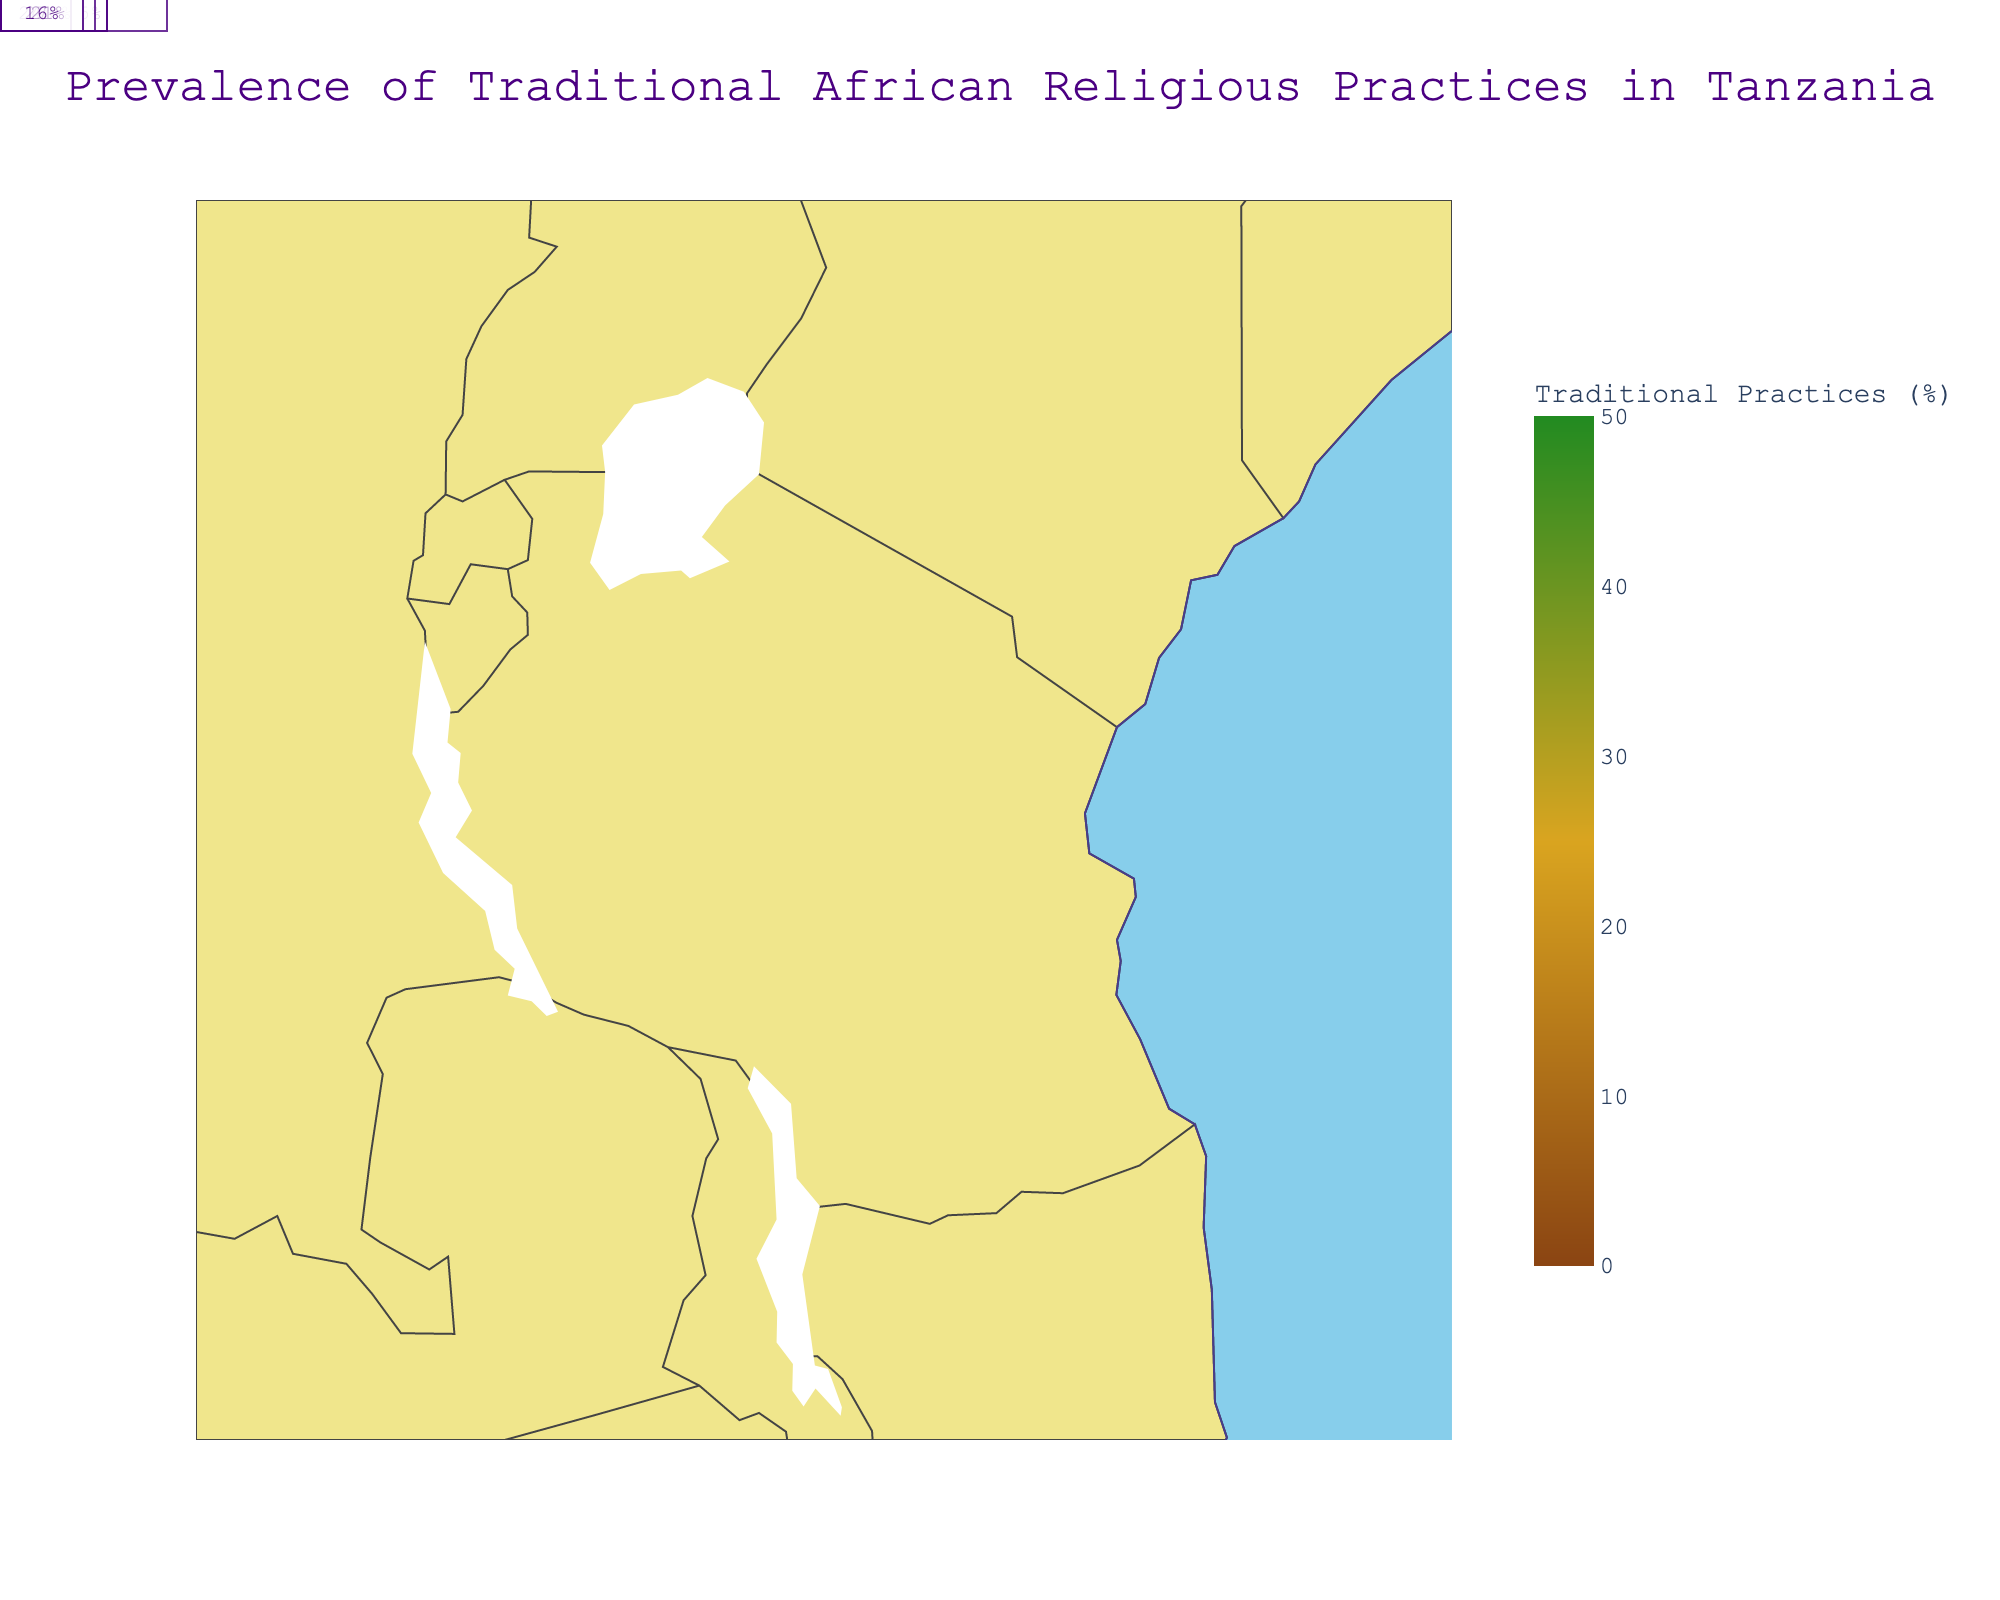What is the title of the figure? The title of the figure is displayed prominently at the top and it describes the subject of the plot. From the information given, the title is stated in the code as "Prevalence of Traditional African Religious Practices in Tanzania".
Answer: Prevalence of Traditional African Religious Practices in Tanzania Which district has the highest prevalence of traditional practices? To determine the district with the highest prevalence, look at the color-coded scale and the corresponding percentages. Zanzibar has the highest percentage at 45%.
Answer: Zanzibar How does the prevalence of traditional practices in Mtwara compare to that in Arusha? First, find Mtwara's prevalence of traditional practices which is 38%. Then, find Arusha's prevalence which is 28%. Comparing the two, Mtwara has a higher prevalence.
Answer: Mtwara has a higher prevalence Which district has the lowest prevalence of traditional practices? Identify the lowest percentage from the color scale and annotations. Mbeya has the lowest prevalence of traditional practices at 12%.
Answer: Mbeya What is the range of traditional practices prevalence across all districts? Find the minimum value which is 12% in Mbeya, and the maximum value which is 45% in Zanzibar. The range is the difference between these values: 45% - 12% = 33%.
Answer: 33% Which district has the highest Christian population percentage and what is this value? Locate the district with the highest percentage in the "Christian Population (%)" column. Mbeya has the highest Christian population percentage at 85%.
Answer: Mbeya with 85% Compare the prevalence of traditional practices in Dar es Salaam and Kigoma Look at Dar es Salaam's prevalence which is 15%, and Kigoma's which is 33%. Kigoma has a higher prevalence than Dar es Salaam.
Answer: Kigoma has a higher prevalence How does traditional practices prevalence in Tanga compare to that in Morogoro? Tanga has a prevalence of 30%, whereas Morogoro has 25%. Tanga's prevalence is higher.
Answer: Tanga's prevalence is higher Calculate the average traditional practices prevalence across all districts. Sum all percentages (15+22+28+19+12+30+25+33+38+17+45+24+27+21+16 = 372) and divide by the number of districts (15). The average is 372/15 = 24.8.
Answer: 24.8% Which district has both a high prevalence of traditional practices and a relatively low Christian population percentage, and what are these values? Look for a district with both high prevalence and lower Christian population. Zanzibar has 45% traditional practices and 35% Christian population.
Answer: Zanzibar with 45% traditional and 35% Christian 